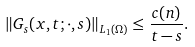<formula> <loc_0><loc_0><loc_500><loc_500>\| G _ { s } ( x , t ; \cdot , s ) \| _ { L _ { 1 } ( \Omega ) } \leq \frac { c ( n ) } { t - s } .</formula> 